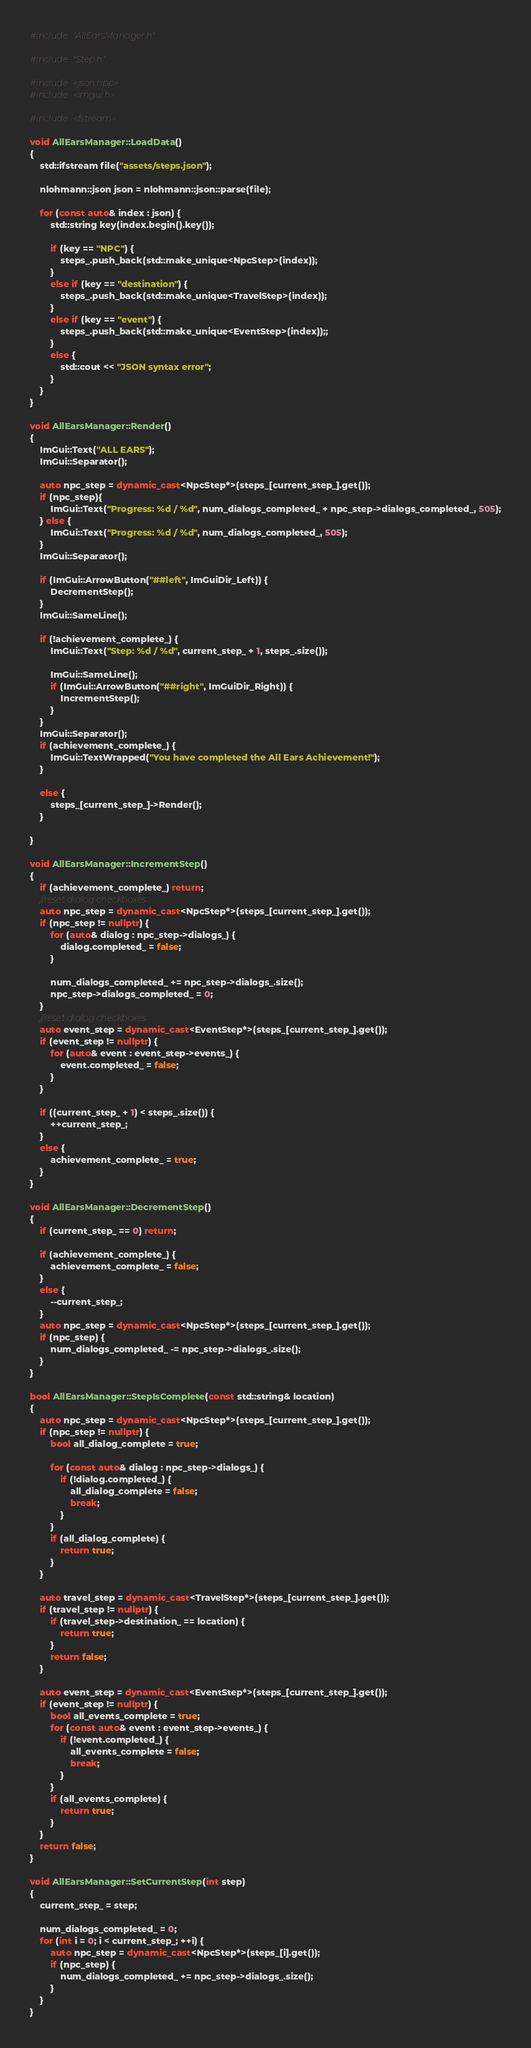<code> <loc_0><loc_0><loc_500><loc_500><_C++_>#include "AllEarsManager.h"

#include "Step.h"

#include <json.hpp>
#include <imgui.h>

#include <fstream>

void AllEarsManager::LoadData()
{
	std::ifstream file("assets/steps.json");

	nlohmann::json json = nlohmann::json::parse(file);

	for (const auto& index : json) {
		std::string key(index.begin().key());

		if (key == "NPC") {
			steps_.push_back(std::make_unique<NpcStep>(index));
		}
		else if (key == "destination") {
			steps_.push_back(std::make_unique<TravelStep>(index));
		}
		else if (key == "event") {
			steps_.push_back(std::make_unique<EventStep>(index));;
		}
		else {
			std::cout << "JSON syntax error";
		}
	}
}

void AllEarsManager::Render()
{
	ImGui::Text("ALL EARS");
	ImGui::Separator();

	auto npc_step = dynamic_cast<NpcStep*>(steps_[current_step_].get());
	if (npc_step){
		ImGui::Text("Progress: %d / %d", num_dialogs_completed_ + npc_step->dialogs_completed_, 505);
	} else {
		ImGui::Text("Progress: %d / %d", num_dialogs_completed_, 505);
	}
	ImGui::Separator();

	if (ImGui::ArrowButton("##left", ImGuiDir_Left)) {
		DecrementStep();
	}
	ImGui::SameLine();

	if (!achievement_complete_) {
		ImGui::Text("Step: %d / %d", current_step_ + 1, steps_.size());

		ImGui::SameLine();
		if (ImGui::ArrowButton("##right", ImGuiDir_Right)) {
			IncrementStep();
		}
	}
	ImGui::Separator();
	if (achievement_complete_) {
		ImGui::TextWrapped("You have completed the All Ears Achievement!");
	}

	else {
		steps_[current_step_]->Render();
	}

}

void AllEarsManager::IncrementStep()
{
	if (achievement_complete_) return;
	//reset dialog checkboxes
	auto npc_step = dynamic_cast<NpcStep*>(steps_[current_step_].get());
	if (npc_step != nullptr) {
		for (auto& dialog : npc_step->dialogs_) {
			dialog.completed_ = false;
		}

		num_dialogs_completed_ += npc_step->dialogs_.size();
		npc_step->dialogs_completed_ = 0;
	}
	//reset dialog checkboxes
	auto event_step = dynamic_cast<EventStep*>(steps_[current_step_].get());
	if (event_step != nullptr) {
		for (auto& event : event_step->events_) {
			event.completed_ = false;
		}
	}

	if ((current_step_ + 1) < steps_.size()) {
		++current_step_;
	}
	else {
		achievement_complete_ = true;
	}
}

void AllEarsManager::DecrementStep()
{
	if (current_step_ == 0) return;

	if (achievement_complete_) {
		achievement_complete_ = false;
	}
	else {
		--current_step_;
	}
	auto npc_step = dynamic_cast<NpcStep*>(steps_[current_step_].get());
	if (npc_step) {
		num_dialogs_completed_ -= npc_step->dialogs_.size();
	}
}

bool AllEarsManager::StepIsComplete(const std::string& location)
{
	auto npc_step = dynamic_cast<NpcStep*>(steps_[current_step_].get());
	if (npc_step != nullptr) {
		bool all_dialog_complete = true;

		for (const auto& dialog : npc_step->dialogs_) {
			if (!dialog.completed_) {
				all_dialog_complete = false;
				break;
			}
		}
		if (all_dialog_complete) {
			return true;
		}
	}

	auto travel_step = dynamic_cast<TravelStep*>(steps_[current_step_].get());
	if (travel_step != nullptr) {
		if (travel_step->destination_ == location) {
			return true;
		}
		return false;
	}

	auto event_step = dynamic_cast<EventStep*>(steps_[current_step_].get());
	if (event_step != nullptr) {
		bool all_events_complete = true;
		for (const auto& event : event_step->events_) {
			if (!event.completed_) {
				all_events_complete = false;
				break;
			}
		}
		if (all_events_complete) {
			return true;
		}
	}
	return false;
}

void AllEarsManager::SetCurrentStep(int step)
{
	current_step_ = step;

	num_dialogs_completed_ = 0;
	for (int i = 0; i < current_step_; ++i) {
		auto npc_step = dynamic_cast<NpcStep*>(steps_[i].get());
		if (npc_step) {
			num_dialogs_completed_ += npc_step->dialogs_.size();
		}
	}
}
</code> 